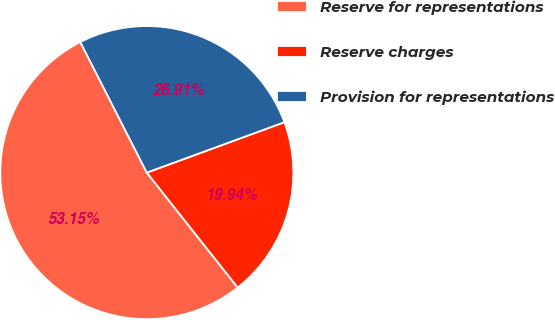Convert chart. <chart><loc_0><loc_0><loc_500><loc_500><pie_chart><fcel>Reserve for representations<fcel>Reserve charges<fcel>Provision for representations<nl><fcel>53.15%<fcel>19.94%<fcel>26.91%<nl></chart> 